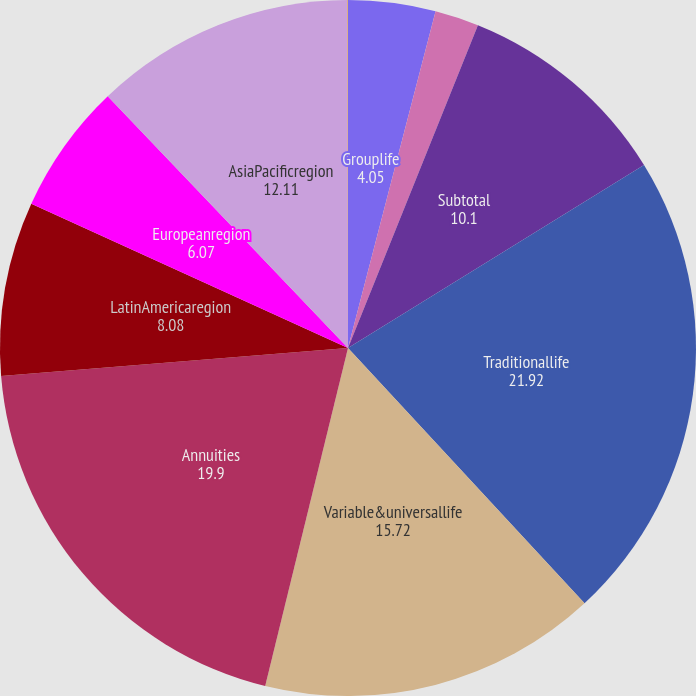Convert chart to OTSL. <chart><loc_0><loc_0><loc_500><loc_500><pie_chart><fcel>Grouplife<fcel>Retirement & savings<fcel>Subtotal<fcel>Traditionallife<fcel>Variable&universallife<fcel>Annuities<fcel>LatinAmericaregion<fcel>Europeanregion<fcel>AsiaPacificregion<fcel>Corporate&Other<nl><fcel>4.05%<fcel>2.04%<fcel>10.1%<fcel>21.92%<fcel>15.72%<fcel>19.9%<fcel>8.08%<fcel>6.07%<fcel>12.11%<fcel>0.02%<nl></chart> 